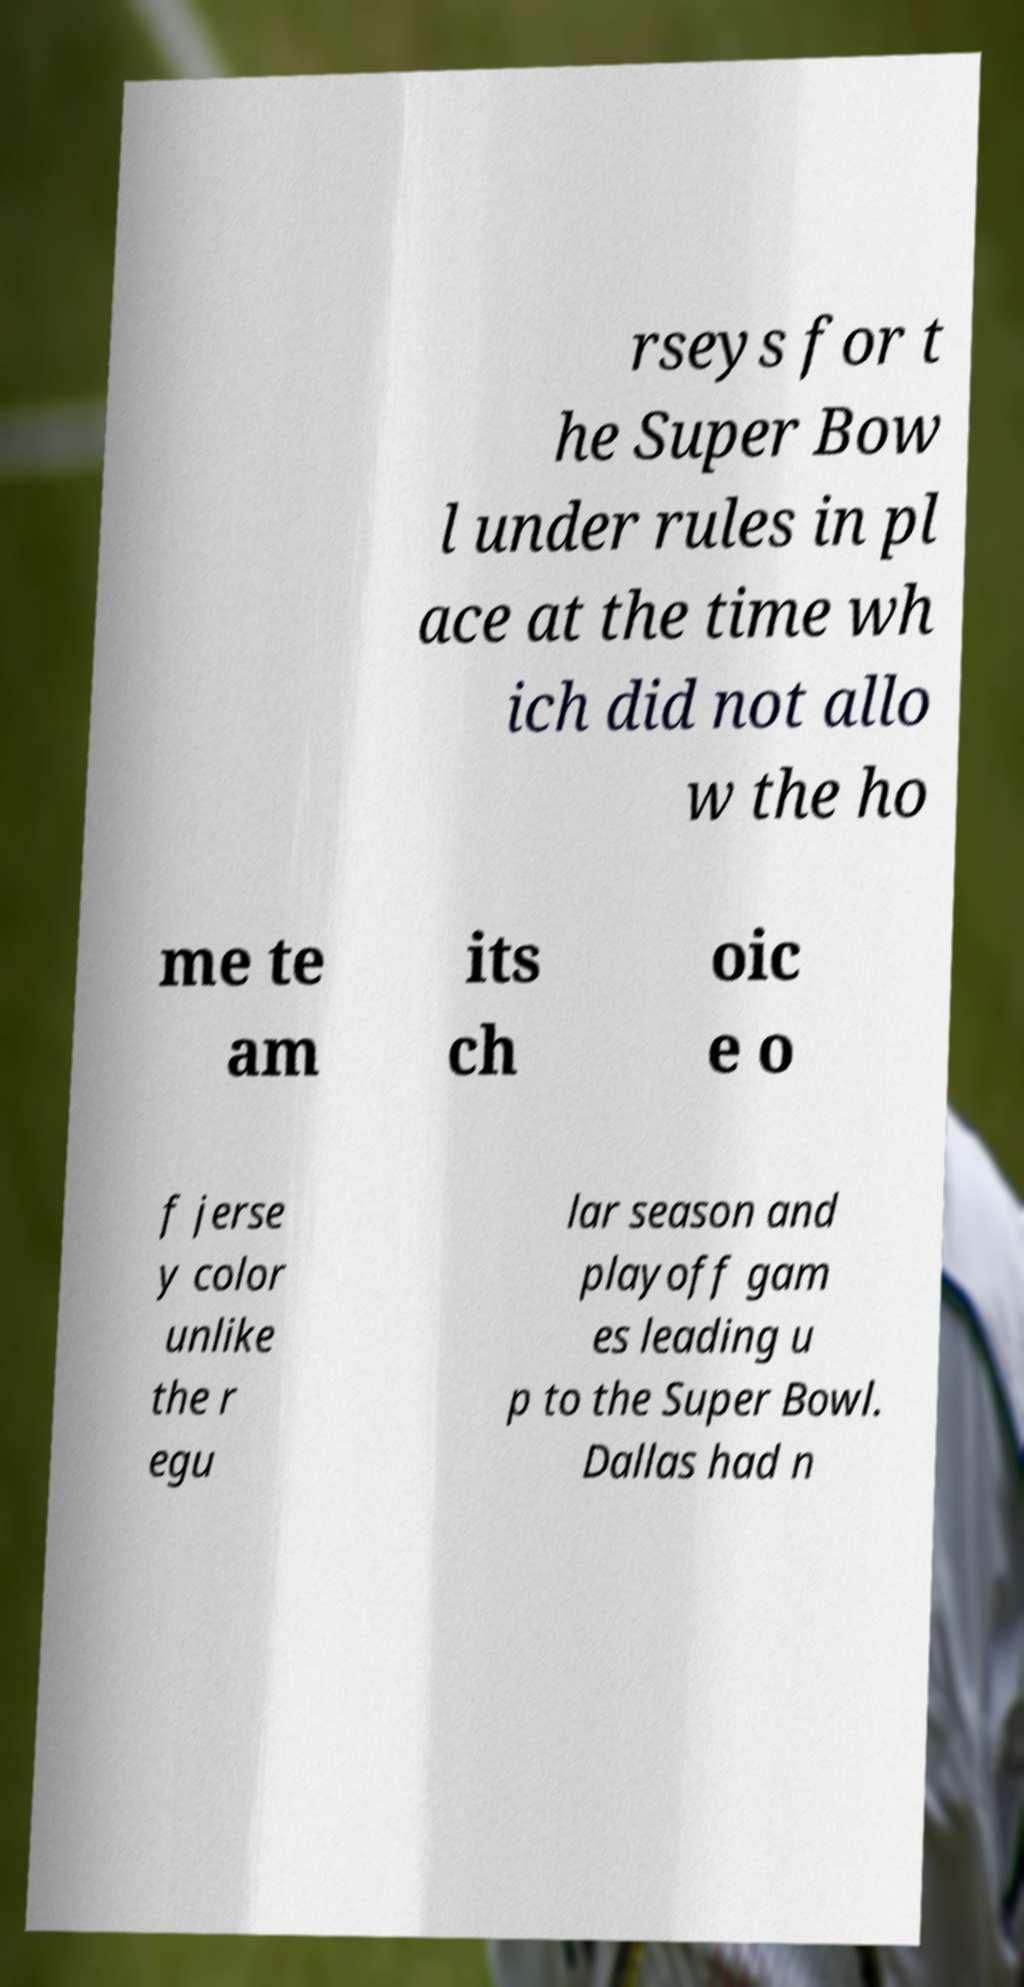Can you accurately transcribe the text from the provided image for me? rseys for t he Super Bow l under rules in pl ace at the time wh ich did not allo w the ho me te am its ch oic e o f jerse y color unlike the r egu lar season and playoff gam es leading u p to the Super Bowl. Dallas had n 